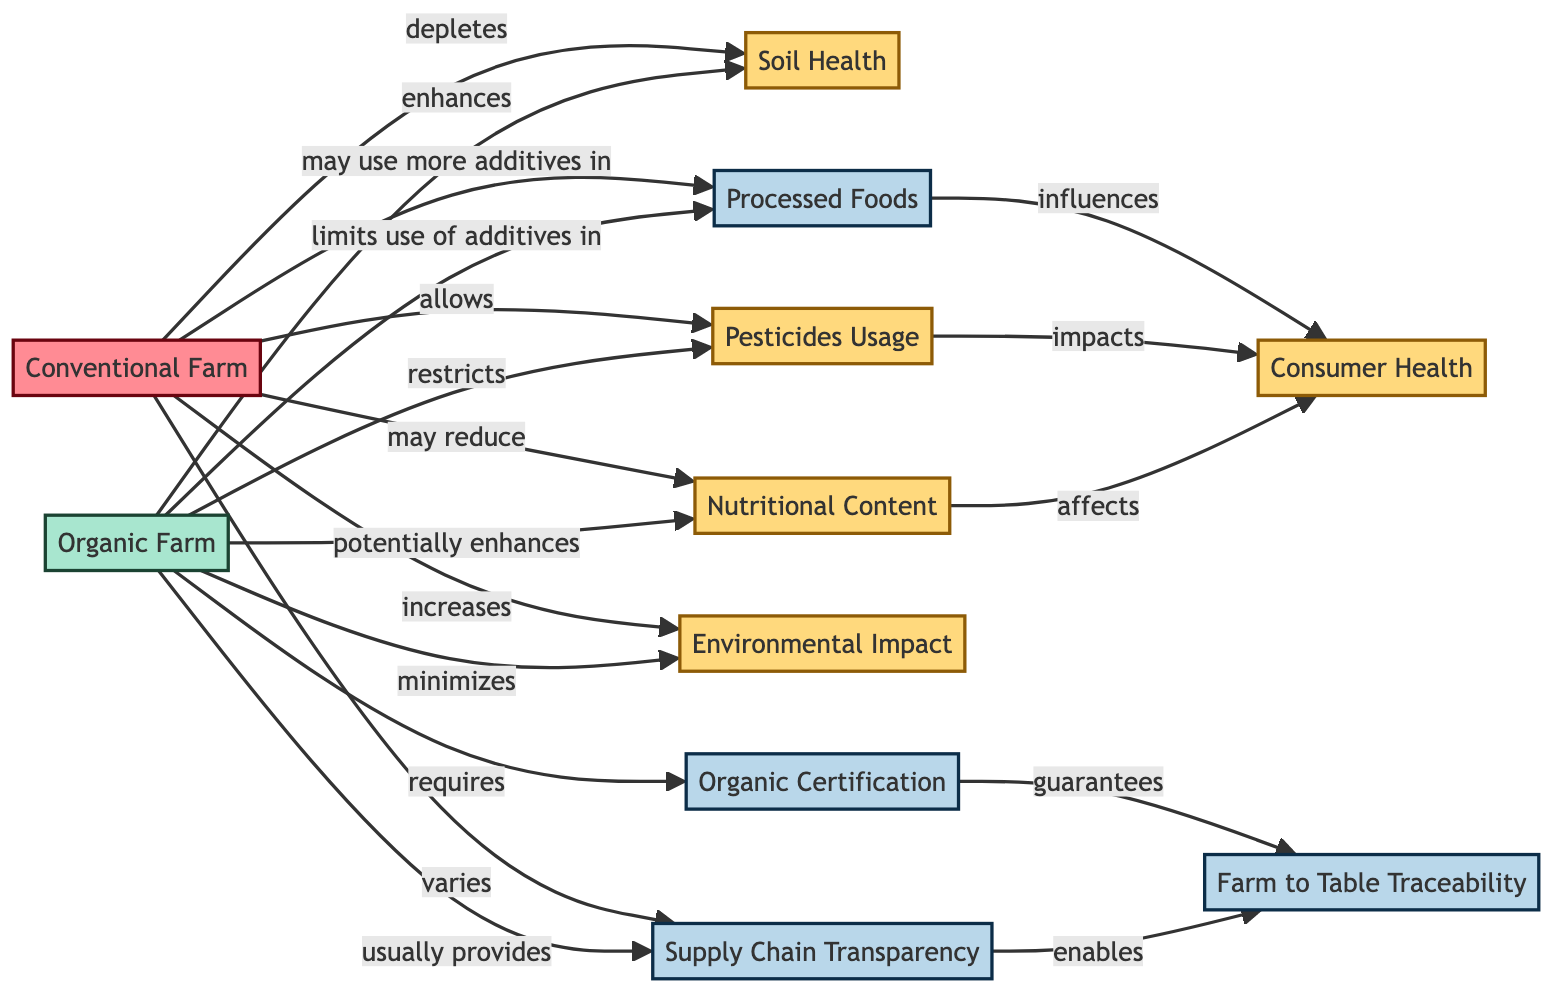What does the Organic Farm enhance? The diagram indicates that the Organic Farm enhances the Soil Health node, which is directly connected by an edge labeled "enhances."
Answer: Soil Health What effect does Conventional Farming have on Soil Health? According to the diagram, Conventional Farming is linked to Soil Health with an edge labeled "depletes," indicating its negative impact.
Answer: depletes How many nodes are there in the diagram? By counting the nodes listed in the data portion, it can be determined that there are a total of 11 nodes present in the diagram.
Answer: 11 Which farming method has a better impact on Environmental Impact? The diagram shows that the Organic Farm minimizes Environmental Impact while the Conventional Farm increases it. This indicates that Organic Farming has a better impact.
Answer: minimizes What is the relationship between Nutritional Content and Consumer Health? The diagram connects Nutritional Content to Consumer Health with an edge indicating it "affects," highlighting the influence that nutritional quality has on health.
Answer: affects Which farming method limits the use of additives in Processed Foods? The diagram states that Organic Farming limits the use of additives in processed foods, as shown by the connected edge labeled "limits use of additives in."
Answer: limits use of additives in What role does Organic Certification play in Farm to Table Traceability? The diagram highlights that Organic Certification guarantees Farm to Table Traceability, indicating that certification is crucial for ensuring traceability.
Answer: guarantees Which method of farming varies in Supply Chain Transparency? The diagram indicates that Conventional Farming has a varying degree of Supply Chain Transparency, as indicated by the labeled edge "varies."
Answer: varies What affects Consumer Health according to the diagram? Both Nutritional Content and Pesticides Usage are identified in the diagram as affecting Consumer Health; this shows the two distinct influences on health.
Answer: Nutritional Content and Pesticides Usage 